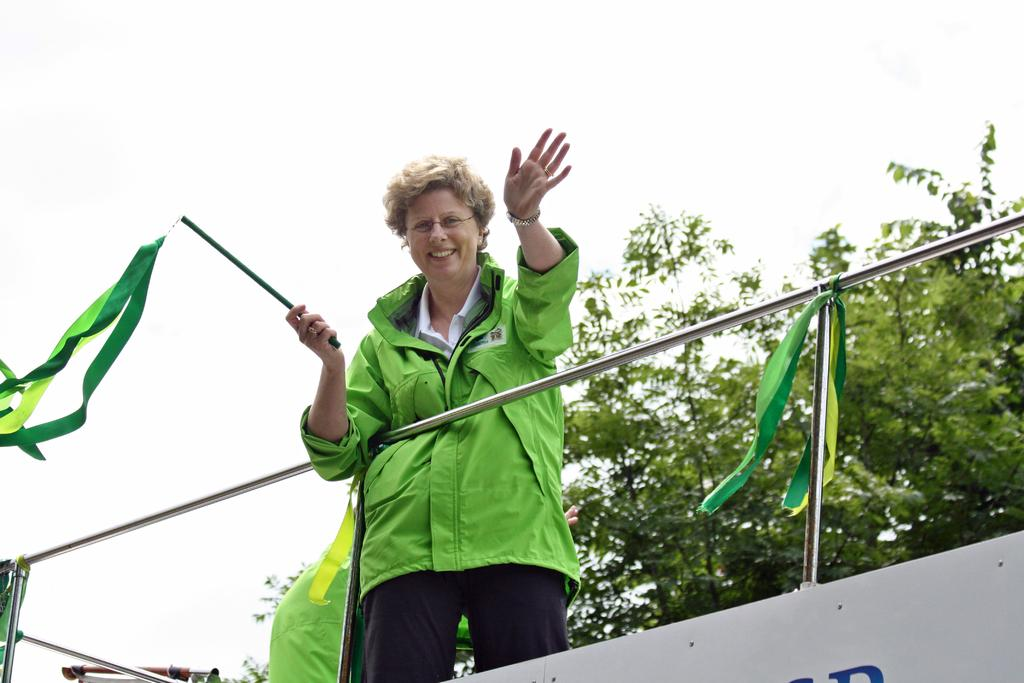What is the main subject of the image? There is a woman standing in the center of the image. What is the woman holding in the image? The woman is holding a stick and ribbons. Can you describe the objects at the bottom of the image? Ribbons are visible at the bottom of the image. What can be seen in the background of the image? There are trees and the sky visible in the background of the image. What type of plant is the woman watering in the image? There is no plant visible in the image, nor is the woman watering anything. 